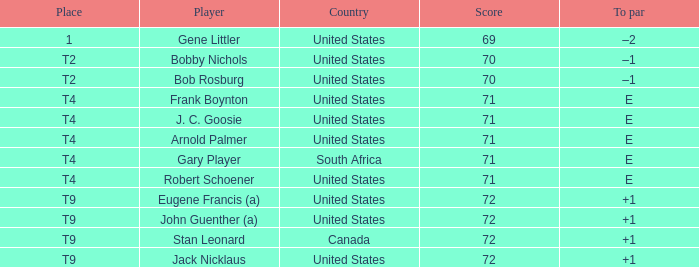What is the to par value when the country is "united states", the place is "t4", and the player is "arnold palmer"? E. 